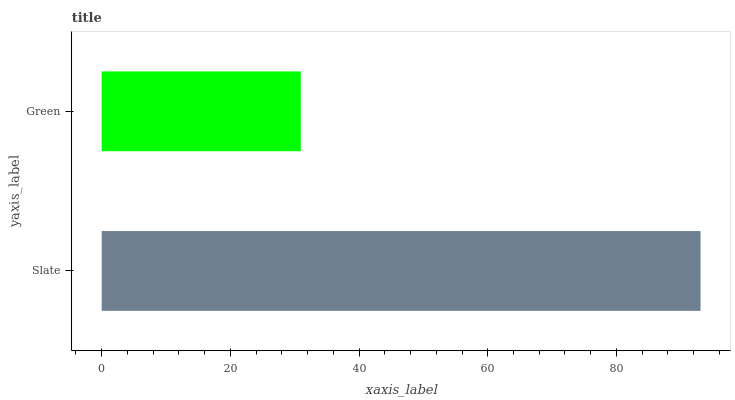Is Green the minimum?
Answer yes or no. Yes. Is Slate the maximum?
Answer yes or no. Yes. Is Green the maximum?
Answer yes or no. No. Is Slate greater than Green?
Answer yes or no. Yes. Is Green less than Slate?
Answer yes or no. Yes. Is Green greater than Slate?
Answer yes or no. No. Is Slate less than Green?
Answer yes or no. No. Is Slate the high median?
Answer yes or no. Yes. Is Green the low median?
Answer yes or no. Yes. Is Green the high median?
Answer yes or no. No. Is Slate the low median?
Answer yes or no. No. 